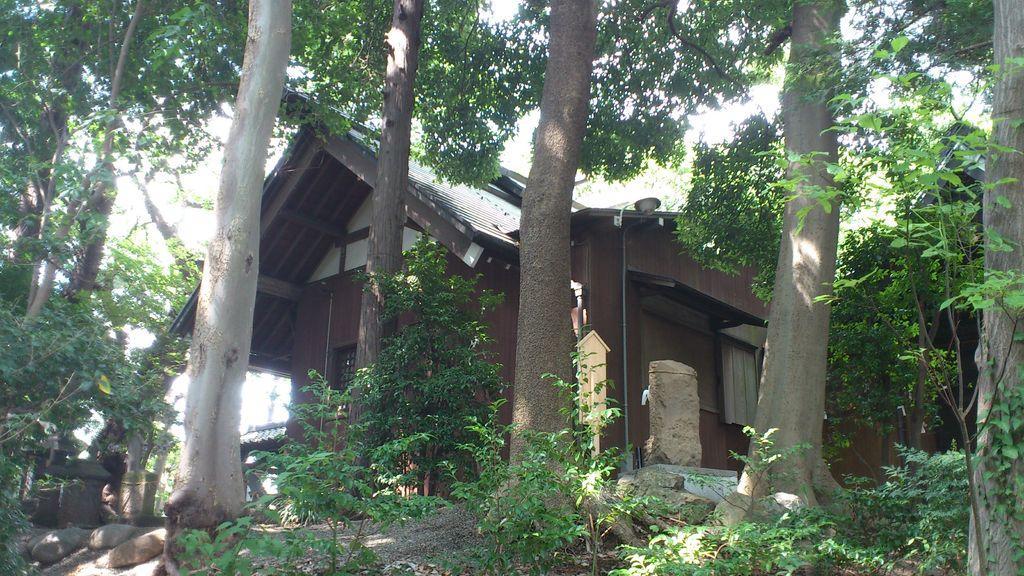Could you give a brief overview of what you see in this image? In the picture I can see a house, plants, trees, rocks and some other objects. In the background I can see the sky. 